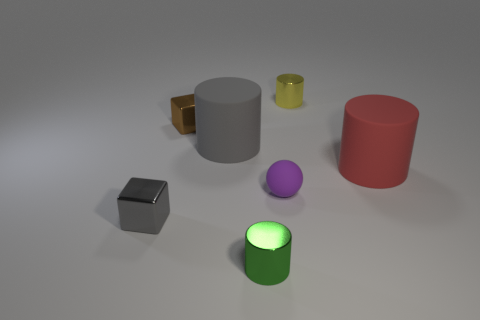Add 3 blocks. How many objects exist? 10 Subtract all cylinders. How many objects are left? 3 Add 7 gray matte cylinders. How many gray matte cylinders exist? 8 Subtract 0 brown cylinders. How many objects are left? 7 Subtract all tiny brown objects. Subtract all purple matte spheres. How many objects are left? 5 Add 6 big rubber things. How many big rubber things are left? 8 